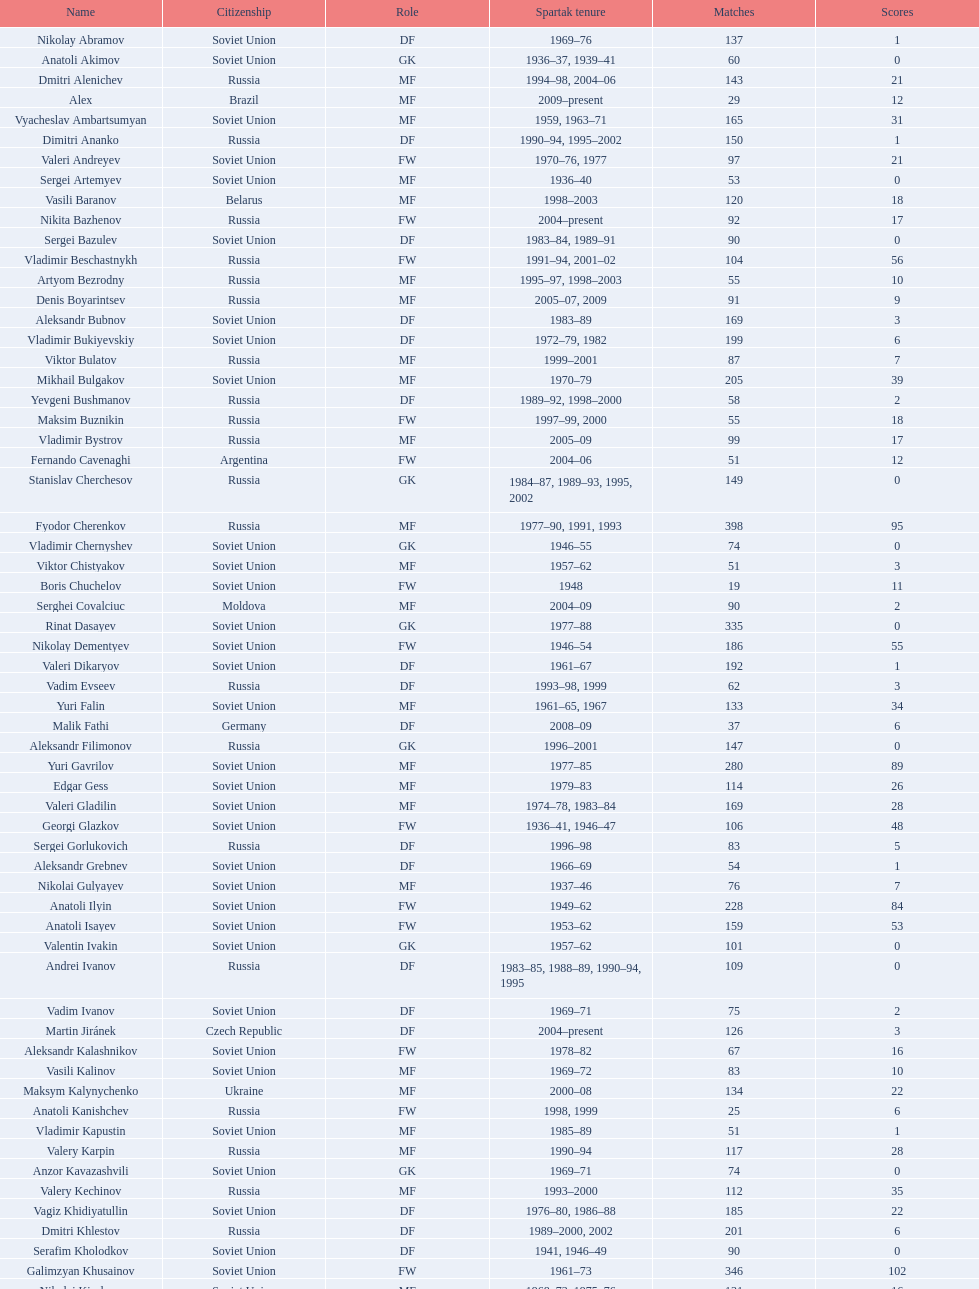How many players had at least 20 league goals scored? 56. 